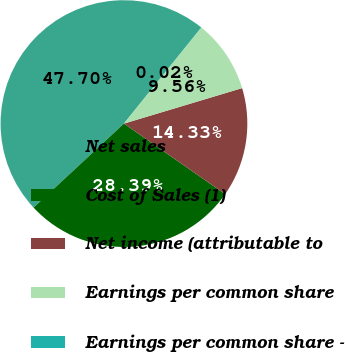<chart> <loc_0><loc_0><loc_500><loc_500><pie_chart><fcel>Net sales<fcel>Cost of Sales (1)<fcel>Net income (attributable to<fcel>Earnings per common share<fcel>Earnings per common share -<nl><fcel>47.7%<fcel>28.39%<fcel>14.33%<fcel>9.56%<fcel>0.02%<nl></chart> 